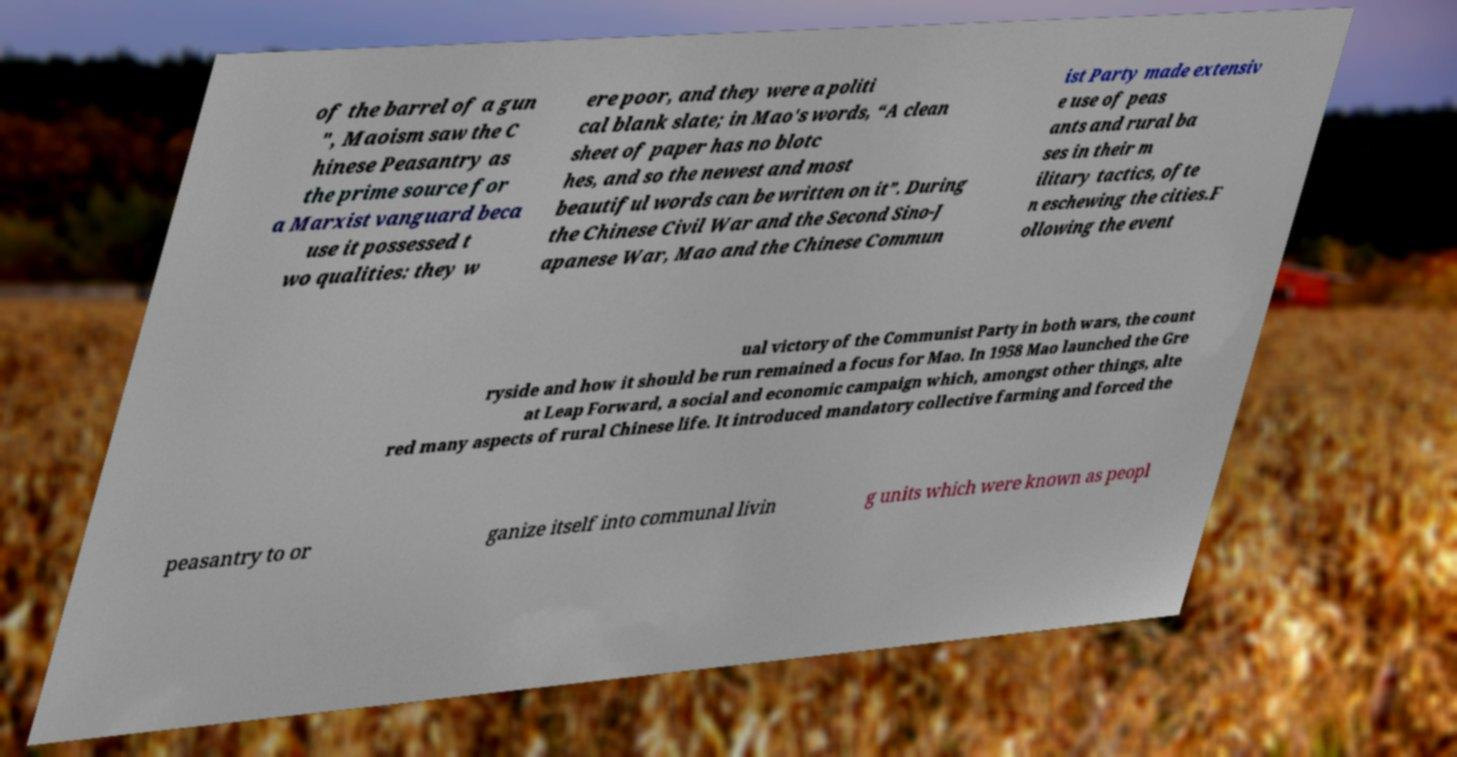For documentation purposes, I need the text within this image transcribed. Could you provide that? of the barrel of a gun ", Maoism saw the C hinese Peasantry as the prime source for a Marxist vanguard beca use it possessed t wo qualities: they w ere poor, and they were a politi cal blank slate; in Mao's words, “A clean sheet of paper has no blotc hes, and so the newest and most beautiful words can be written on it”. During the Chinese Civil War and the Second Sino-J apanese War, Mao and the Chinese Commun ist Party made extensiv e use of peas ants and rural ba ses in their m ilitary tactics, ofte n eschewing the cities.F ollowing the event ual victory of the Communist Party in both wars, the count ryside and how it should be run remained a focus for Mao. In 1958 Mao launched the Gre at Leap Forward, a social and economic campaign which, amongst other things, alte red many aspects of rural Chinese life. It introduced mandatory collective farming and forced the peasantry to or ganize itself into communal livin g units which were known as peopl 